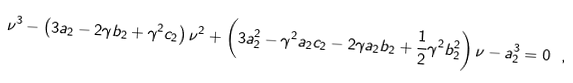Convert formula to latex. <formula><loc_0><loc_0><loc_500><loc_500>\nu ^ { 3 } - \left ( 3 a _ { 2 } - 2 \gamma b _ { 2 } + \gamma ^ { 2 } c _ { 2 } \right ) \nu ^ { 2 } + \left ( 3 a _ { 2 } ^ { 2 } - \gamma ^ { 2 } a _ { 2 } c _ { 2 } - 2 \gamma a _ { 2 } b _ { 2 } + \frac { 1 } { 2 } \gamma ^ { 2 } b _ { 2 } ^ { 2 } \right ) \nu - a _ { 2 } ^ { 3 } = 0 \ ,</formula> 